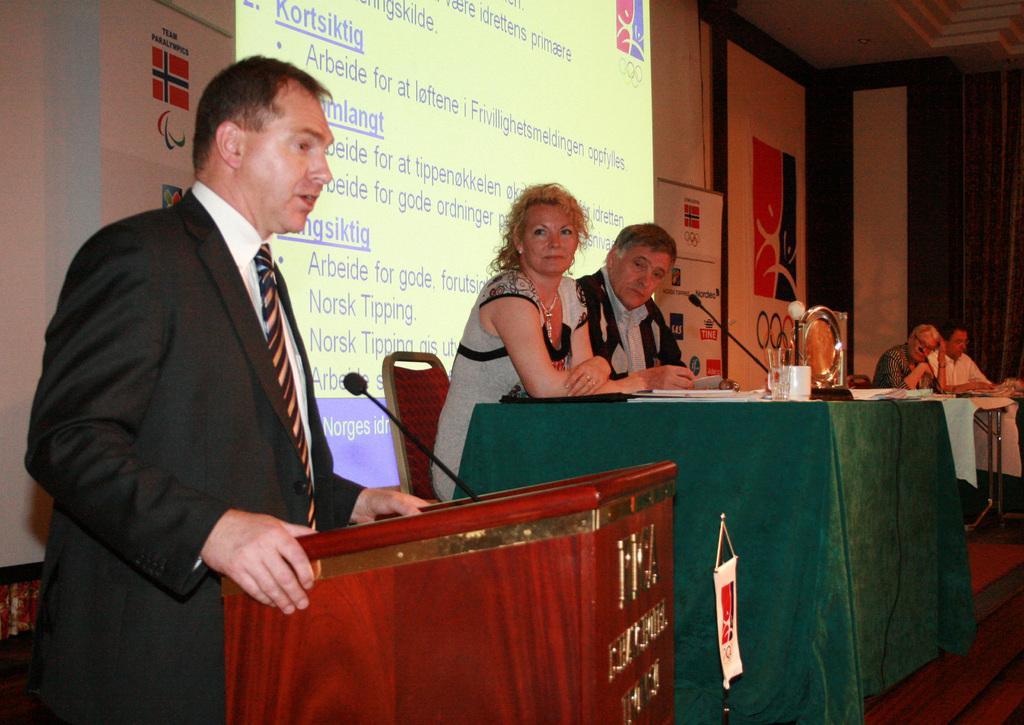Please provide a concise description of this image. In this image on the left there is a man, he wears a suit, shirt, tie, in front of him there is a podium and mic. In the middle there is a man and woman, they are sitting, in front of them there is a table on that there are glasses, cups, mic and sheet. On the right there are two men sitting in front of a table. In the background there is screen, posters. 